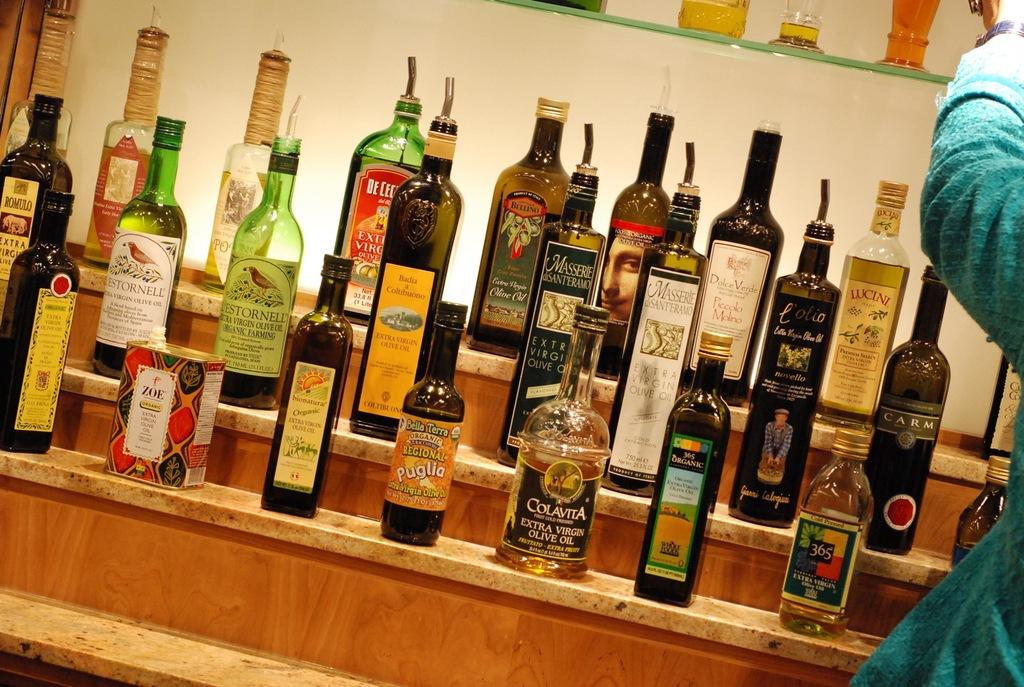<image>
Provide a brief description of the given image. A bottle with an orange label that reads, "Bella Terra Organic" sits in the middle of the front row. 